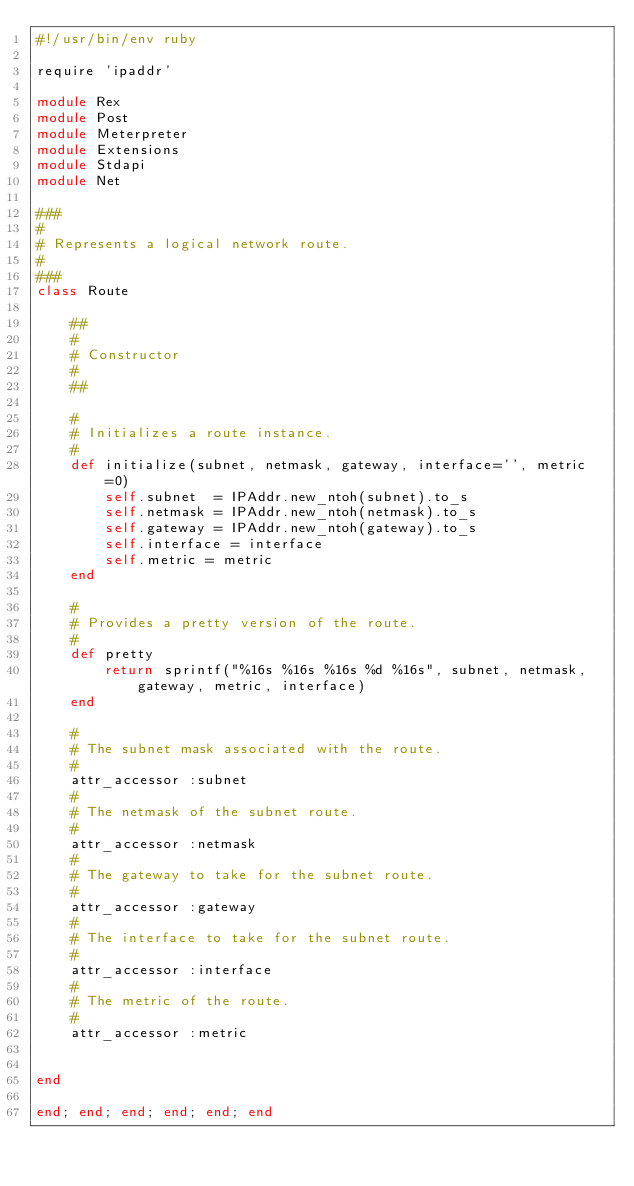Convert code to text. <code><loc_0><loc_0><loc_500><loc_500><_Ruby_>#!/usr/bin/env ruby

require 'ipaddr'

module Rex
module Post
module Meterpreter
module Extensions
module Stdapi
module Net

###
#
# Represents a logical network route.
#
###
class Route

	##
	#
	# Constructor
	#
	##

	#
	# Initializes a route instance.
	#
	def initialize(subnet, netmask, gateway, interface='', metric=0)
		self.subnet  = IPAddr.new_ntoh(subnet).to_s
		self.netmask = IPAddr.new_ntoh(netmask).to_s
		self.gateway = IPAddr.new_ntoh(gateway).to_s
		self.interface = interface
		self.metric = metric
	end

	#
	# Provides a pretty version of the route.
	#
	def pretty
		return sprintf("%16s %16s %16s %d %16s", subnet, netmask, gateway, metric, interface)
	end

	#
	# The subnet mask associated with the route.
	#
	attr_accessor :subnet
	#
	# The netmask of the subnet route.
	#
	attr_accessor :netmask
	#
	# The gateway to take for the subnet route.
	#
	attr_accessor :gateway
	#
	# The interface to take for the subnet route.
	#
	attr_accessor :interface
	#
	# The metric of the route.
	#
	attr_accessor :metric


end

end; end; end; end; end; end
</code> 